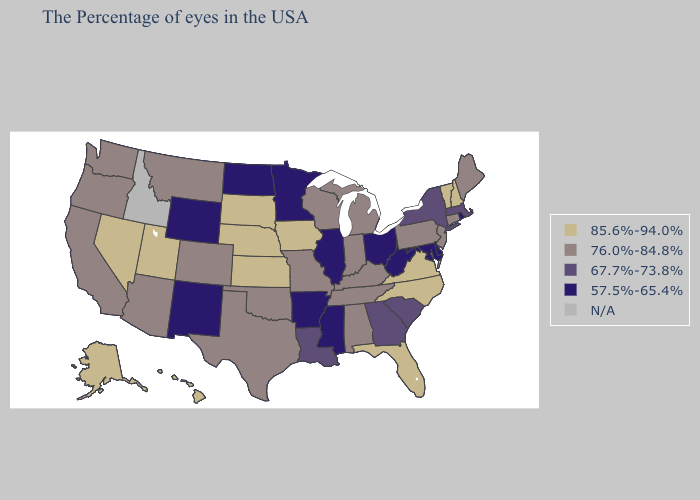What is the highest value in the MidWest ?
Keep it brief. 85.6%-94.0%. Does Pennsylvania have the highest value in the Northeast?
Give a very brief answer. No. Does the map have missing data?
Write a very short answer. Yes. Name the states that have a value in the range N/A?
Keep it brief. Idaho. Which states have the lowest value in the South?
Keep it brief. Delaware, Maryland, West Virginia, Mississippi, Arkansas. Which states hav the highest value in the MidWest?
Answer briefly. Iowa, Kansas, Nebraska, South Dakota. Does the map have missing data?
Answer briefly. Yes. Name the states that have a value in the range 67.7%-73.8%?
Quick response, please. Massachusetts, New York, South Carolina, Georgia, Louisiana. What is the highest value in the USA?
Write a very short answer. 85.6%-94.0%. Name the states that have a value in the range 67.7%-73.8%?
Write a very short answer. Massachusetts, New York, South Carolina, Georgia, Louisiana. Does Iowa have the lowest value in the USA?
Be succinct. No. Among the states that border Arizona , which have the highest value?
Answer briefly. Utah, Nevada. 